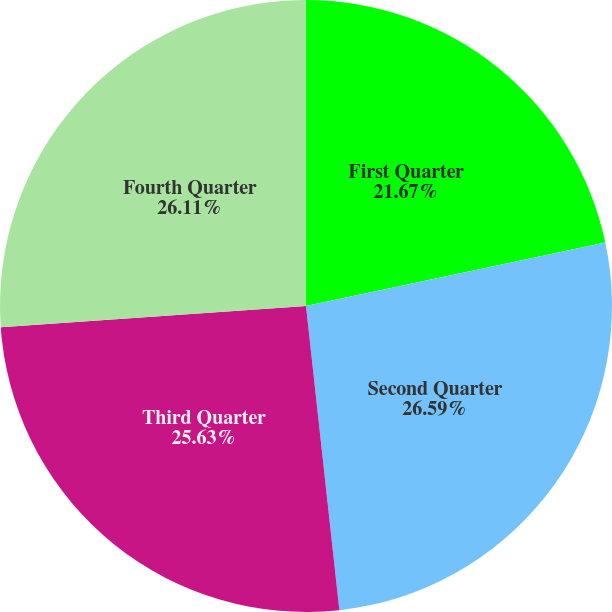Convert chart. <chart><loc_0><loc_0><loc_500><loc_500><pie_chart><fcel>First Quarter<fcel>Second Quarter<fcel>Third Quarter<fcel>Fourth Quarter<nl><fcel>21.67%<fcel>26.59%<fcel>25.63%<fcel>26.11%<nl></chart> 